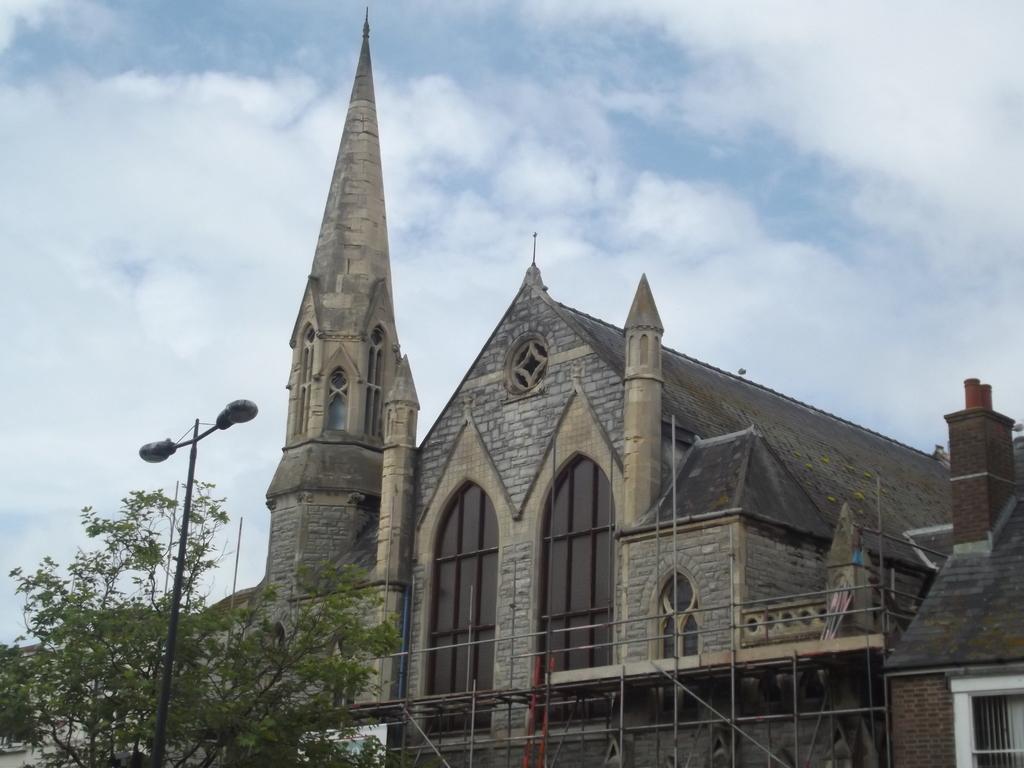Can you describe this image briefly? In this image there is a building, in front of the building there is a tree and a pole with street light. In the background there is the sky. 